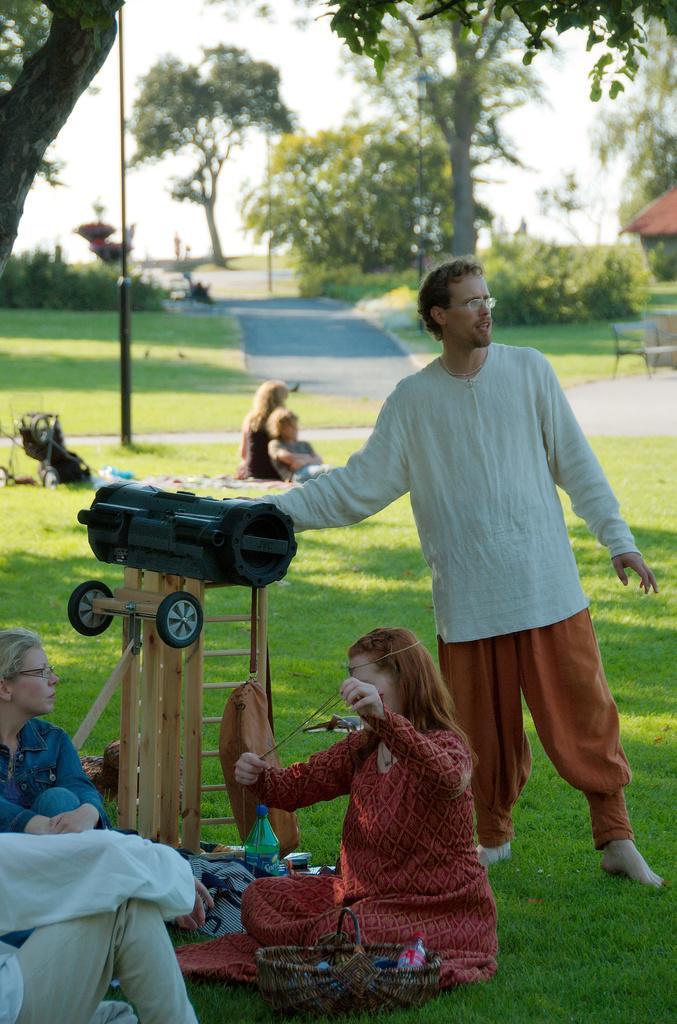Describe this image in one or two sentences. In this image in the foreground there are persons sitting and there is a basket on the ground and there is a man standing and there is a stand and on the stand there is an object which is black in colour. In the middle there is grass on the ground and there are persons sitting and there is an object which is black in colour. In the background there are trees. On the right side there is a tent and there is an empty chair. 